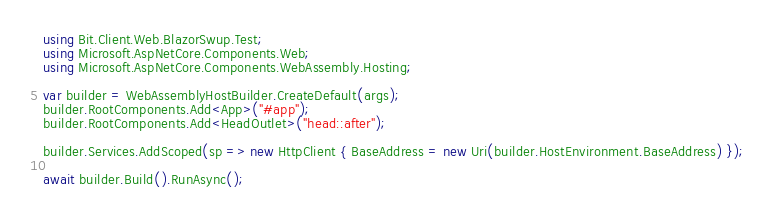<code> <loc_0><loc_0><loc_500><loc_500><_C#_>using Bit.Client.Web.BlazorSwup.Test;
using Microsoft.AspNetCore.Components.Web;
using Microsoft.AspNetCore.Components.WebAssembly.Hosting;

var builder = WebAssemblyHostBuilder.CreateDefault(args);
builder.RootComponents.Add<App>("#app");
builder.RootComponents.Add<HeadOutlet>("head::after");

builder.Services.AddScoped(sp => new HttpClient { BaseAddress = new Uri(builder.HostEnvironment.BaseAddress) });

await builder.Build().RunAsync();
</code> 